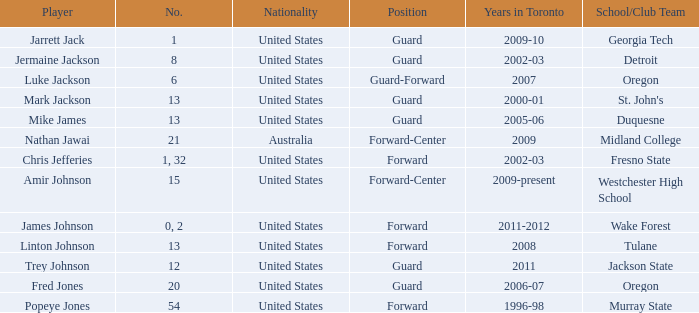Give me the full table as a dictionary. {'header': ['Player', 'No.', 'Nationality', 'Position', 'Years in Toronto', 'School/Club Team'], 'rows': [['Jarrett Jack', '1', 'United States', 'Guard', '2009-10', 'Georgia Tech'], ['Jermaine Jackson', '8', 'United States', 'Guard', '2002-03', 'Detroit'], ['Luke Jackson', '6', 'United States', 'Guard-Forward', '2007', 'Oregon'], ['Mark Jackson', '13', 'United States', 'Guard', '2000-01', "St. John's"], ['Mike James', '13', 'United States', 'Guard', '2005-06', 'Duquesne'], ['Nathan Jawai', '21', 'Australia', 'Forward-Center', '2009', 'Midland College'], ['Chris Jefferies', '1, 32', 'United States', 'Forward', '2002-03', 'Fresno State'], ['Amir Johnson', '15', 'United States', 'Forward-Center', '2009-present', 'Westchester High School'], ['James Johnson', '0, 2', 'United States', 'Forward', '2011-2012', 'Wake Forest'], ['Linton Johnson', '13', 'United States', 'Forward', '2008', 'Tulane'], ['Trey Johnson', '12', 'United States', 'Guard', '2011', 'Jackson State'], ['Fred Jones', '20', 'United States', 'Guard', '2006-07', 'Oregon'], ['Popeye Jones', '54', 'United States', 'Forward', '1996-98', 'Murray State']]} What educational/institution team does trey johnson belong to? Jackson State. 